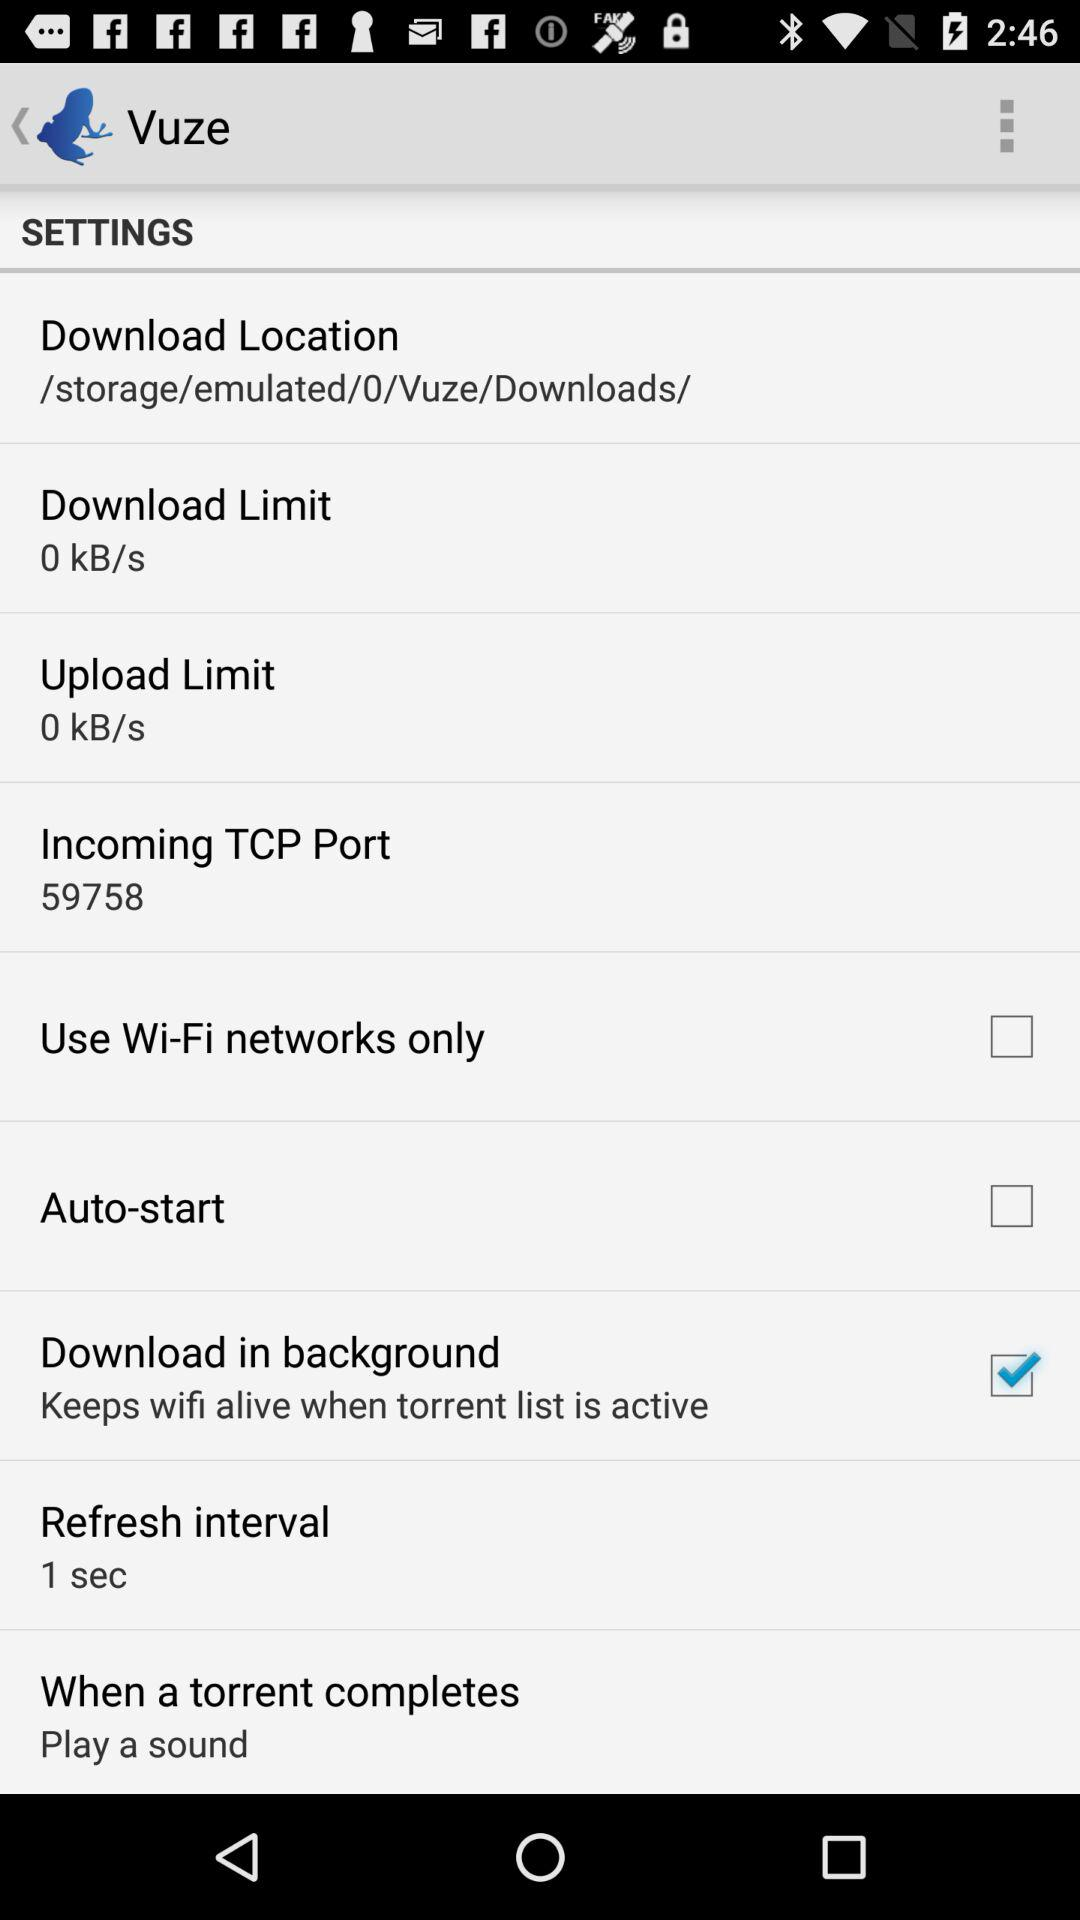What is the download limit? The download limit is 0 kB/s. 